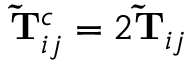<formula> <loc_0><loc_0><loc_500><loc_500>\widetilde { T } _ { i j } ^ { c } = 2 \widetilde { T } _ { i j }</formula> 